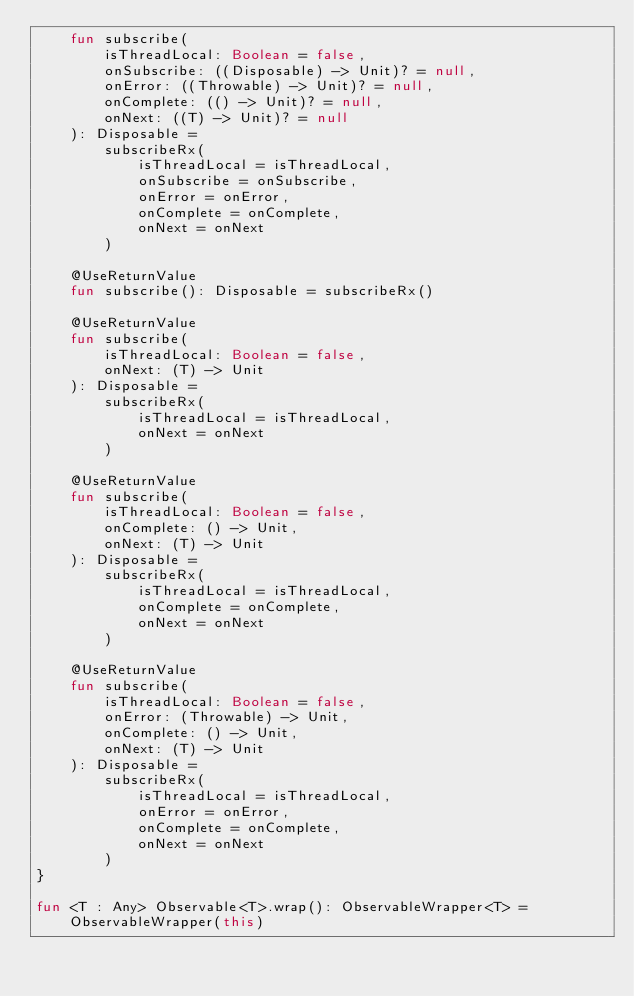<code> <loc_0><loc_0><loc_500><loc_500><_Kotlin_>    fun subscribe(
        isThreadLocal: Boolean = false,
        onSubscribe: ((Disposable) -> Unit)? = null,
        onError: ((Throwable) -> Unit)? = null,
        onComplete: (() -> Unit)? = null,
        onNext: ((T) -> Unit)? = null
    ): Disposable =
        subscribeRx(
            isThreadLocal = isThreadLocal,
            onSubscribe = onSubscribe,
            onError = onError,
            onComplete = onComplete,
            onNext = onNext
        )

    @UseReturnValue
    fun subscribe(): Disposable = subscribeRx()

    @UseReturnValue
    fun subscribe(
        isThreadLocal: Boolean = false,
        onNext: (T) -> Unit
    ): Disposable =
        subscribeRx(
            isThreadLocal = isThreadLocal,
            onNext = onNext
        )

    @UseReturnValue
    fun subscribe(
        isThreadLocal: Boolean = false,
        onComplete: () -> Unit,
        onNext: (T) -> Unit
    ): Disposable =
        subscribeRx(
            isThreadLocal = isThreadLocal,
            onComplete = onComplete,
            onNext = onNext
        )

    @UseReturnValue
    fun subscribe(
        isThreadLocal: Boolean = false,
        onError: (Throwable) -> Unit,
        onComplete: () -> Unit,
        onNext: (T) -> Unit
    ): Disposable =
        subscribeRx(
            isThreadLocal = isThreadLocal,
            onError = onError,
            onComplete = onComplete,
            onNext = onNext
        )
}

fun <T : Any> Observable<T>.wrap(): ObservableWrapper<T> = ObservableWrapper(this)
</code> 